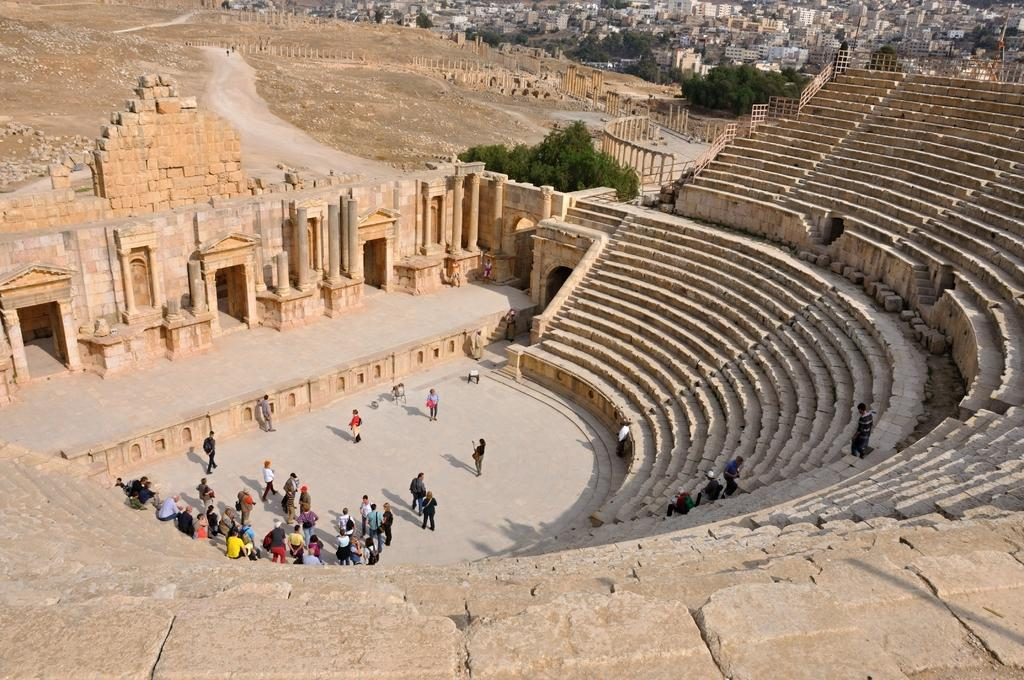What is the main focus of the image? There are people in the center of the image. What architectural feature is present in the image? There is a staircase in the image. What type of structure is in the center of the image? There is a stone structure in the center of the image. What can be seen in the distance in the image? There are buildings and trees in the background of the image. Can you see the destruction caused by the lake in the image? There is no lake present in the image, and therefore no destruction caused by it can be observed. 